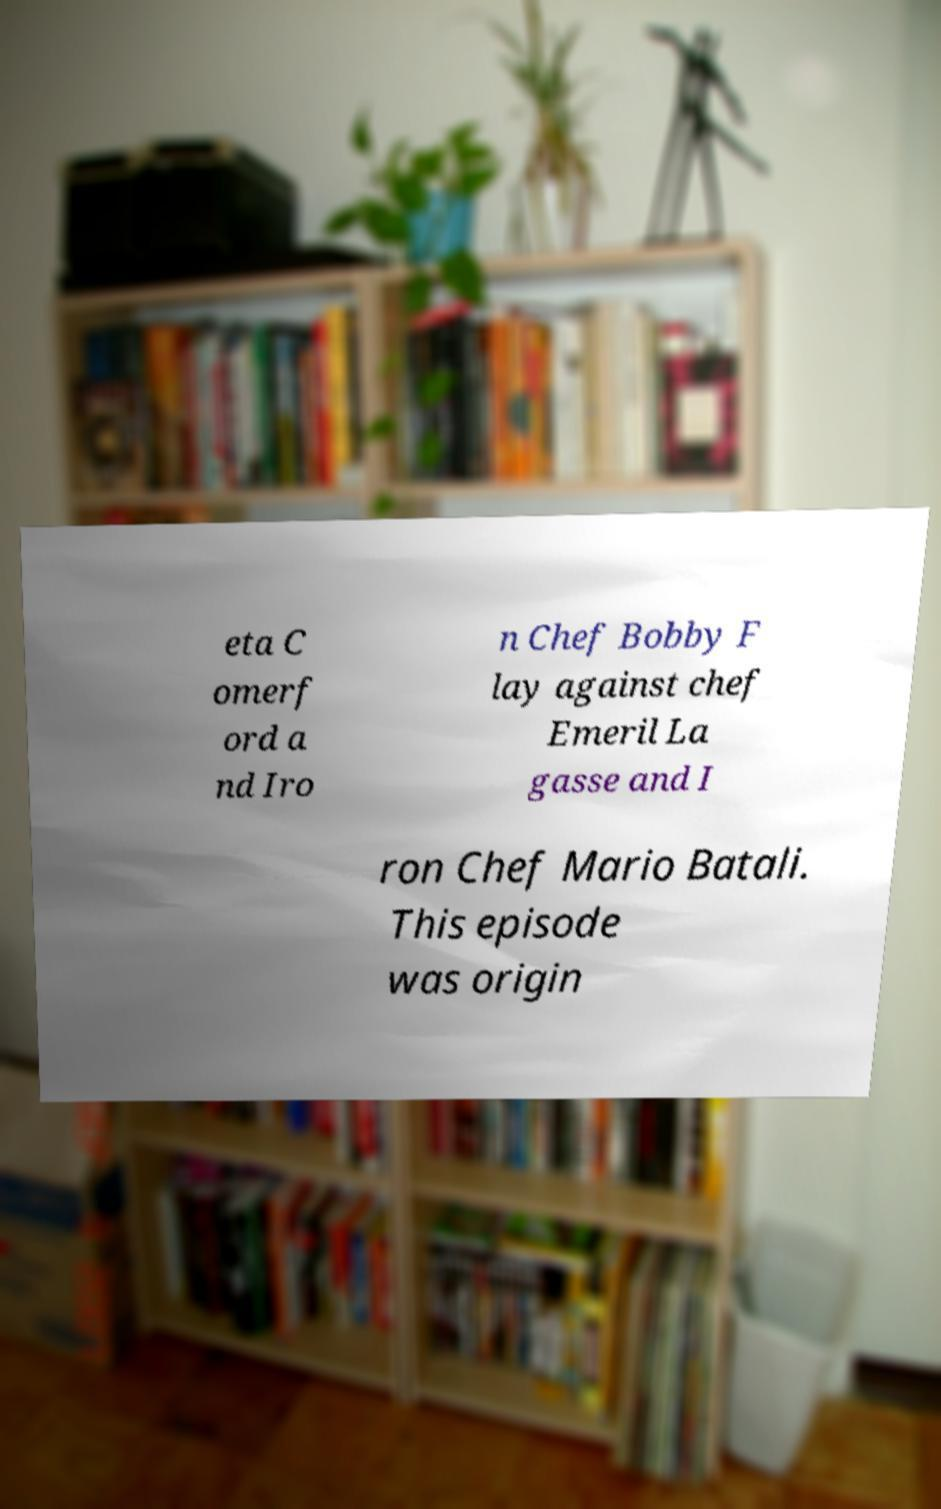Please read and relay the text visible in this image. What does it say? eta C omerf ord a nd Iro n Chef Bobby F lay against chef Emeril La gasse and I ron Chef Mario Batali. This episode was origin 